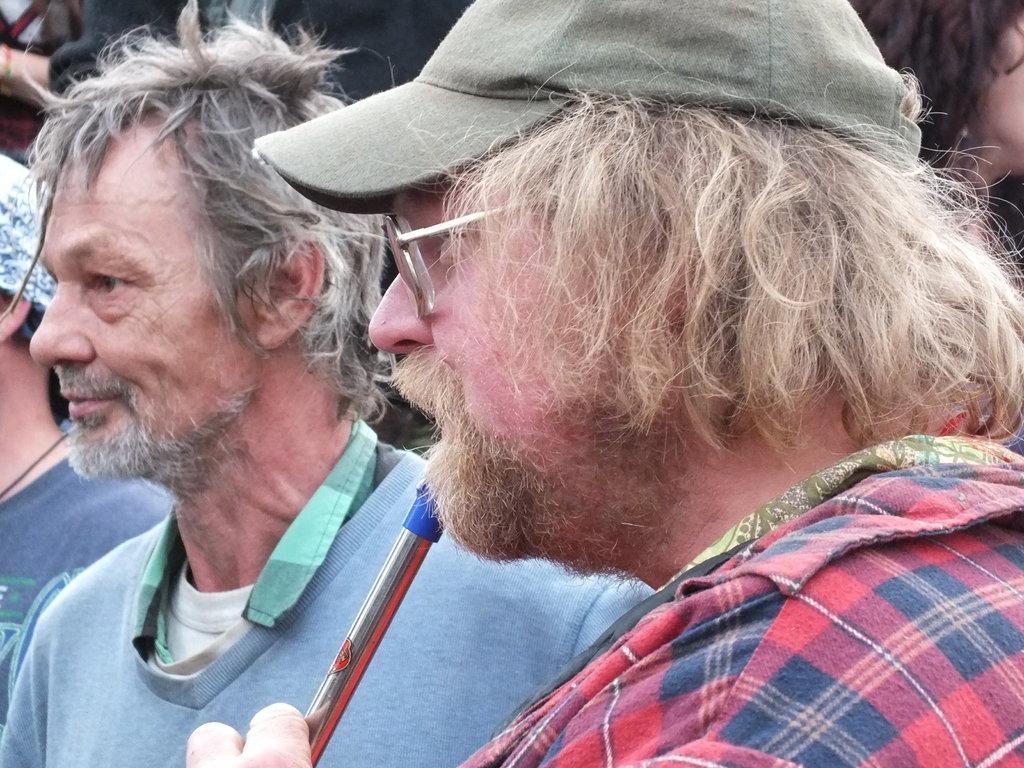Please provide a concise description of this image. In this picture there are two men on the right and left side of the image and there are other people behind them. 